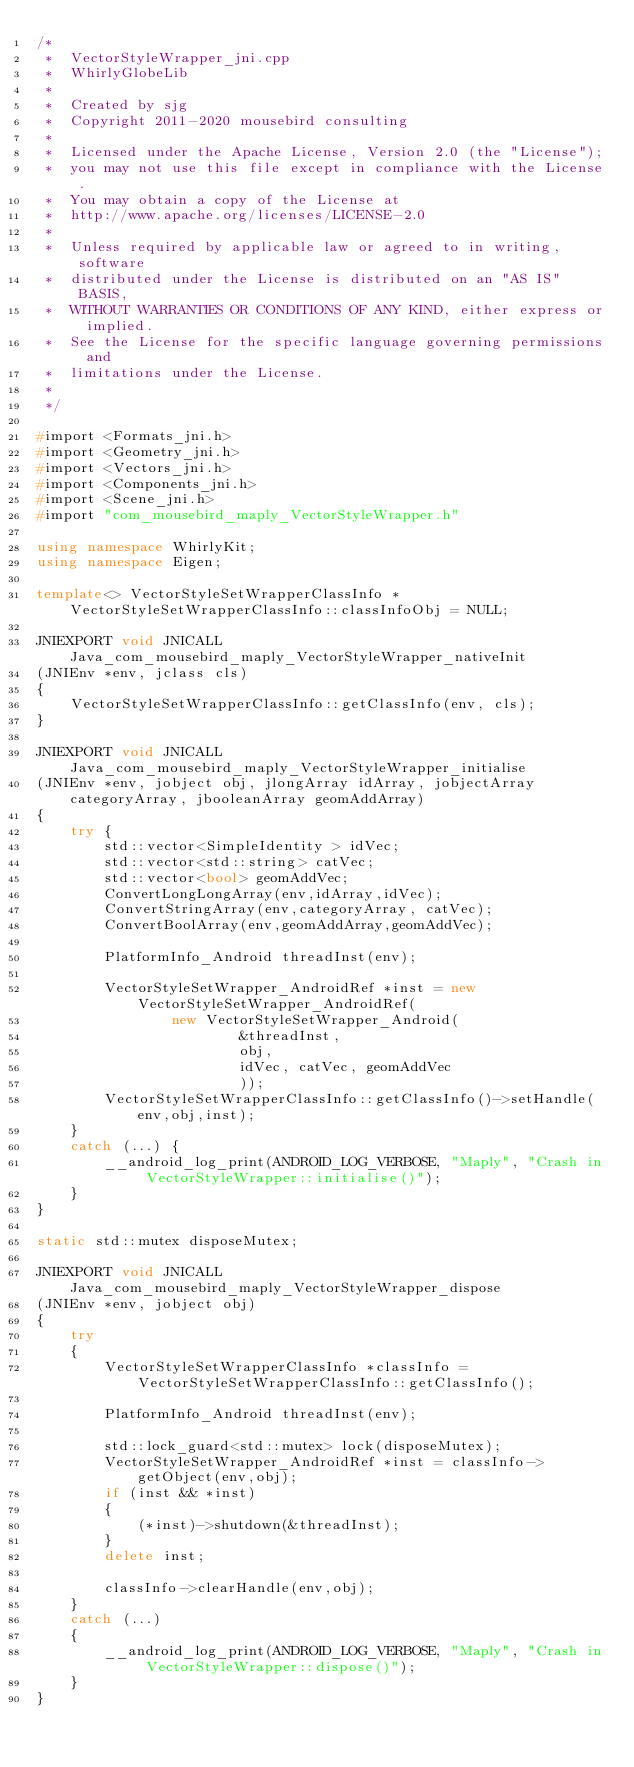Convert code to text. <code><loc_0><loc_0><loc_500><loc_500><_C++_>/*
 *  VectorStyleWrapper_jni.cpp
 *  WhirlyGlobeLib
 *
 *  Created by sjg
 *  Copyright 2011-2020 mousebird consulting
 *
 *  Licensed under the Apache License, Version 2.0 (the "License");
 *  you may not use this file except in compliance with the License.
 *  You may obtain a copy of the License at
 *  http://www.apache.org/licenses/LICENSE-2.0
 *
 *  Unless required by applicable law or agreed to in writing, software
 *  distributed under the License is distributed on an "AS IS" BASIS,
 *  WITHOUT WARRANTIES OR CONDITIONS OF ANY KIND, either express or implied.
 *  See the License for the specific language governing permissions and
 *  limitations under the License.
 *
 */

#import <Formats_jni.h>
#import <Geometry_jni.h>
#import <Vectors_jni.h>
#import <Components_jni.h>
#import <Scene_jni.h>
#import "com_mousebird_maply_VectorStyleWrapper.h"

using namespace WhirlyKit;
using namespace Eigen;

template<> VectorStyleSetWrapperClassInfo *VectorStyleSetWrapperClassInfo::classInfoObj = NULL;

JNIEXPORT void JNICALL Java_com_mousebird_maply_VectorStyleWrapper_nativeInit
(JNIEnv *env, jclass cls)
{
    VectorStyleSetWrapperClassInfo::getClassInfo(env, cls);
}

JNIEXPORT void JNICALL Java_com_mousebird_maply_VectorStyleWrapper_initialise
(JNIEnv *env, jobject obj, jlongArray idArray, jobjectArray categoryArray, jbooleanArray geomAddArray)
{
    try {
        std::vector<SimpleIdentity > idVec;
        std::vector<std::string> catVec;
        std::vector<bool> geomAddVec;
        ConvertLongLongArray(env,idArray,idVec);
        ConvertStringArray(env,categoryArray, catVec);
        ConvertBoolArray(env,geomAddArray,geomAddVec);

        PlatformInfo_Android threadInst(env);

        VectorStyleSetWrapper_AndroidRef *inst = new VectorStyleSetWrapper_AndroidRef(
                new VectorStyleSetWrapper_Android(
                        &threadInst,
                        obj,
                        idVec, catVec, geomAddVec
                        ));
        VectorStyleSetWrapperClassInfo::getClassInfo()->setHandle(env,obj,inst);
    }
    catch (...) {
        __android_log_print(ANDROID_LOG_VERBOSE, "Maply", "Crash in VectorStyleWrapper::initialise()");
    }
}

static std::mutex disposeMutex;

JNIEXPORT void JNICALL Java_com_mousebird_maply_VectorStyleWrapper_dispose
(JNIEnv *env, jobject obj)
{
    try
    {
        VectorStyleSetWrapperClassInfo *classInfo = VectorStyleSetWrapperClassInfo::getClassInfo();

        PlatformInfo_Android threadInst(env);

        std::lock_guard<std::mutex> lock(disposeMutex);
        VectorStyleSetWrapper_AndroidRef *inst = classInfo->getObject(env,obj);
        if (inst && *inst)
        {
            (*inst)->shutdown(&threadInst);
        }
        delete inst;

        classInfo->clearHandle(env,obj);
    }
    catch (...)
    {
        __android_log_print(ANDROID_LOG_VERBOSE, "Maply", "Crash in VectorStyleWrapper::dispose()");
    }
}

</code> 